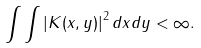Convert formula to latex. <formula><loc_0><loc_0><loc_500><loc_500>\int \int \left | K ( x , y ) \right | ^ { 2 } d x d y < \infty .</formula> 